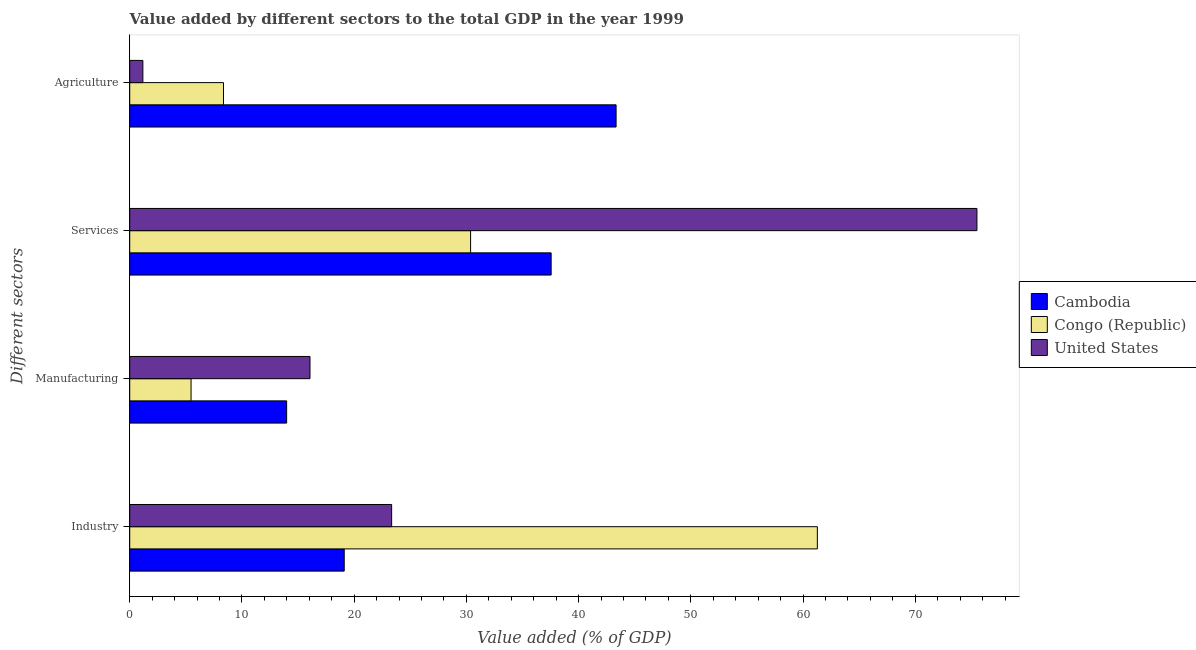How many different coloured bars are there?
Your answer should be compact. 3. How many groups of bars are there?
Keep it short and to the point. 4. What is the label of the 2nd group of bars from the top?
Offer a very short reply. Services. What is the value added by agricultural sector in United States?
Provide a succinct answer. 1.17. Across all countries, what is the maximum value added by agricultural sector?
Give a very brief answer. 43.34. Across all countries, what is the minimum value added by services sector?
Your answer should be very brief. 30.37. In which country was the value added by agricultural sector maximum?
Provide a short and direct response. Cambodia. In which country was the value added by services sector minimum?
Give a very brief answer. Congo (Republic). What is the total value added by services sector in the graph?
Ensure brevity in your answer.  143.41. What is the difference between the value added by manufacturing sector in United States and that in Cambodia?
Provide a succinct answer. 2.08. What is the difference between the value added by manufacturing sector in Cambodia and the value added by industrial sector in United States?
Give a very brief answer. -9.36. What is the average value added by agricultural sector per country?
Make the answer very short. 17.62. What is the difference between the value added by services sector and value added by manufacturing sector in Cambodia?
Your answer should be compact. 23.57. What is the ratio of the value added by agricultural sector in Cambodia to that in Congo (Republic)?
Make the answer very short. 5.19. Is the value added by industrial sector in Congo (Republic) less than that in Cambodia?
Ensure brevity in your answer.  No. What is the difference between the highest and the second highest value added by services sector?
Offer a very short reply. 37.94. What is the difference between the highest and the lowest value added by industrial sector?
Offer a very short reply. 42.16. In how many countries, is the value added by services sector greater than the average value added by services sector taken over all countries?
Keep it short and to the point. 1. Is the sum of the value added by services sector in Congo (Republic) and United States greater than the maximum value added by manufacturing sector across all countries?
Your response must be concise. Yes. Is it the case that in every country, the sum of the value added by industrial sector and value added by manufacturing sector is greater than the sum of value added by agricultural sector and value added by services sector?
Offer a very short reply. No. What does the 2nd bar from the top in Services represents?
Your response must be concise. Congo (Republic). What does the 1st bar from the bottom in Manufacturing represents?
Make the answer very short. Cambodia. Are all the bars in the graph horizontal?
Ensure brevity in your answer.  Yes. How many countries are there in the graph?
Provide a short and direct response. 3. Are the values on the major ticks of X-axis written in scientific E-notation?
Your answer should be very brief. No. Does the graph contain grids?
Ensure brevity in your answer.  No. Where does the legend appear in the graph?
Your response must be concise. Center right. How many legend labels are there?
Make the answer very short. 3. What is the title of the graph?
Your answer should be compact. Value added by different sectors to the total GDP in the year 1999. Does "Turks and Caicos Islands" appear as one of the legend labels in the graph?
Your answer should be very brief. No. What is the label or title of the X-axis?
Make the answer very short. Value added (% of GDP). What is the label or title of the Y-axis?
Offer a terse response. Different sectors. What is the Value added (% of GDP) of Cambodia in Industry?
Make the answer very short. 19.11. What is the Value added (% of GDP) in Congo (Republic) in Industry?
Make the answer very short. 61.27. What is the Value added (% of GDP) of United States in Industry?
Provide a short and direct response. 23.34. What is the Value added (% of GDP) in Cambodia in Manufacturing?
Your answer should be compact. 13.98. What is the Value added (% of GDP) of Congo (Republic) in Manufacturing?
Offer a very short reply. 5.46. What is the Value added (% of GDP) of United States in Manufacturing?
Keep it short and to the point. 16.06. What is the Value added (% of GDP) in Cambodia in Services?
Offer a very short reply. 37.55. What is the Value added (% of GDP) of Congo (Republic) in Services?
Give a very brief answer. 30.37. What is the Value added (% of GDP) of United States in Services?
Make the answer very short. 75.49. What is the Value added (% of GDP) of Cambodia in Agriculture?
Provide a short and direct response. 43.34. What is the Value added (% of GDP) of Congo (Republic) in Agriculture?
Give a very brief answer. 8.36. What is the Value added (% of GDP) in United States in Agriculture?
Your answer should be very brief. 1.17. Across all Different sectors, what is the maximum Value added (% of GDP) of Cambodia?
Offer a terse response. 43.34. Across all Different sectors, what is the maximum Value added (% of GDP) in Congo (Republic)?
Provide a short and direct response. 61.27. Across all Different sectors, what is the maximum Value added (% of GDP) of United States?
Make the answer very short. 75.49. Across all Different sectors, what is the minimum Value added (% of GDP) in Cambodia?
Your response must be concise. 13.98. Across all Different sectors, what is the minimum Value added (% of GDP) in Congo (Republic)?
Offer a very short reply. 5.46. Across all Different sectors, what is the minimum Value added (% of GDP) of United States?
Give a very brief answer. 1.17. What is the total Value added (% of GDP) of Cambodia in the graph?
Make the answer very short. 113.98. What is the total Value added (% of GDP) of Congo (Republic) in the graph?
Your response must be concise. 105.46. What is the total Value added (% of GDP) of United States in the graph?
Your response must be concise. 116.06. What is the difference between the Value added (% of GDP) of Cambodia in Industry and that in Manufacturing?
Make the answer very short. 5.13. What is the difference between the Value added (% of GDP) of Congo (Republic) in Industry and that in Manufacturing?
Offer a terse response. 55.81. What is the difference between the Value added (% of GDP) of United States in Industry and that in Manufacturing?
Offer a terse response. 7.28. What is the difference between the Value added (% of GDP) of Cambodia in Industry and that in Services?
Your answer should be very brief. -18.44. What is the difference between the Value added (% of GDP) in Congo (Republic) in Industry and that in Services?
Your answer should be compact. 30.9. What is the difference between the Value added (% of GDP) of United States in Industry and that in Services?
Ensure brevity in your answer.  -52.15. What is the difference between the Value added (% of GDP) of Cambodia in Industry and that in Agriculture?
Ensure brevity in your answer.  -24.22. What is the difference between the Value added (% of GDP) of Congo (Republic) in Industry and that in Agriculture?
Give a very brief answer. 52.92. What is the difference between the Value added (% of GDP) of United States in Industry and that in Agriculture?
Offer a very short reply. 22.17. What is the difference between the Value added (% of GDP) in Cambodia in Manufacturing and that in Services?
Make the answer very short. -23.57. What is the difference between the Value added (% of GDP) in Congo (Republic) in Manufacturing and that in Services?
Ensure brevity in your answer.  -24.91. What is the difference between the Value added (% of GDP) in United States in Manufacturing and that in Services?
Provide a succinct answer. -59.43. What is the difference between the Value added (% of GDP) in Cambodia in Manufacturing and that in Agriculture?
Make the answer very short. -29.36. What is the difference between the Value added (% of GDP) of Congo (Republic) in Manufacturing and that in Agriculture?
Your answer should be compact. -2.89. What is the difference between the Value added (% of GDP) of United States in Manufacturing and that in Agriculture?
Give a very brief answer. 14.89. What is the difference between the Value added (% of GDP) in Cambodia in Services and that in Agriculture?
Give a very brief answer. -5.79. What is the difference between the Value added (% of GDP) in Congo (Republic) in Services and that in Agriculture?
Provide a succinct answer. 22.02. What is the difference between the Value added (% of GDP) of United States in Services and that in Agriculture?
Your response must be concise. 74.32. What is the difference between the Value added (% of GDP) in Cambodia in Industry and the Value added (% of GDP) in Congo (Republic) in Manufacturing?
Offer a very short reply. 13.65. What is the difference between the Value added (% of GDP) of Cambodia in Industry and the Value added (% of GDP) of United States in Manufacturing?
Your answer should be very brief. 3.05. What is the difference between the Value added (% of GDP) in Congo (Republic) in Industry and the Value added (% of GDP) in United States in Manufacturing?
Your response must be concise. 45.21. What is the difference between the Value added (% of GDP) of Cambodia in Industry and the Value added (% of GDP) of Congo (Republic) in Services?
Offer a very short reply. -11.26. What is the difference between the Value added (% of GDP) in Cambodia in Industry and the Value added (% of GDP) in United States in Services?
Ensure brevity in your answer.  -56.38. What is the difference between the Value added (% of GDP) in Congo (Republic) in Industry and the Value added (% of GDP) in United States in Services?
Give a very brief answer. -14.22. What is the difference between the Value added (% of GDP) of Cambodia in Industry and the Value added (% of GDP) of Congo (Republic) in Agriculture?
Provide a short and direct response. 10.76. What is the difference between the Value added (% of GDP) in Cambodia in Industry and the Value added (% of GDP) in United States in Agriculture?
Ensure brevity in your answer.  17.94. What is the difference between the Value added (% of GDP) in Congo (Republic) in Industry and the Value added (% of GDP) in United States in Agriculture?
Ensure brevity in your answer.  60.1. What is the difference between the Value added (% of GDP) of Cambodia in Manufacturing and the Value added (% of GDP) of Congo (Republic) in Services?
Provide a succinct answer. -16.39. What is the difference between the Value added (% of GDP) of Cambodia in Manufacturing and the Value added (% of GDP) of United States in Services?
Your answer should be compact. -61.51. What is the difference between the Value added (% of GDP) of Congo (Republic) in Manufacturing and the Value added (% of GDP) of United States in Services?
Offer a terse response. -70.03. What is the difference between the Value added (% of GDP) of Cambodia in Manufacturing and the Value added (% of GDP) of Congo (Republic) in Agriculture?
Ensure brevity in your answer.  5.63. What is the difference between the Value added (% of GDP) of Cambodia in Manufacturing and the Value added (% of GDP) of United States in Agriculture?
Provide a short and direct response. 12.81. What is the difference between the Value added (% of GDP) in Congo (Republic) in Manufacturing and the Value added (% of GDP) in United States in Agriculture?
Your response must be concise. 4.29. What is the difference between the Value added (% of GDP) in Cambodia in Services and the Value added (% of GDP) in Congo (Republic) in Agriculture?
Provide a succinct answer. 29.19. What is the difference between the Value added (% of GDP) of Cambodia in Services and the Value added (% of GDP) of United States in Agriculture?
Provide a short and direct response. 36.38. What is the difference between the Value added (% of GDP) of Congo (Republic) in Services and the Value added (% of GDP) of United States in Agriculture?
Your answer should be very brief. 29.2. What is the average Value added (% of GDP) in Cambodia per Different sectors?
Your response must be concise. 28.5. What is the average Value added (% of GDP) of Congo (Republic) per Different sectors?
Provide a short and direct response. 26.37. What is the average Value added (% of GDP) in United States per Different sectors?
Ensure brevity in your answer.  29.02. What is the difference between the Value added (% of GDP) in Cambodia and Value added (% of GDP) in Congo (Republic) in Industry?
Keep it short and to the point. -42.16. What is the difference between the Value added (% of GDP) of Cambodia and Value added (% of GDP) of United States in Industry?
Make the answer very short. -4.22. What is the difference between the Value added (% of GDP) of Congo (Republic) and Value added (% of GDP) of United States in Industry?
Offer a very short reply. 37.93. What is the difference between the Value added (% of GDP) of Cambodia and Value added (% of GDP) of Congo (Republic) in Manufacturing?
Provide a short and direct response. 8.52. What is the difference between the Value added (% of GDP) in Cambodia and Value added (% of GDP) in United States in Manufacturing?
Keep it short and to the point. -2.08. What is the difference between the Value added (% of GDP) in Congo (Republic) and Value added (% of GDP) in United States in Manufacturing?
Your answer should be compact. -10.6. What is the difference between the Value added (% of GDP) in Cambodia and Value added (% of GDP) in Congo (Republic) in Services?
Your answer should be very brief. 7.18. What is the difference between the Value added (% of GDP) of Cambodia and Value added (% of GDP) of United States in Services?
Your answer should be compact. -37.94. What is the difference between the Value added (% of GDP) of Congo (Republic) and Value added (% of GDP) of United States in Services?
Ensure brevity in your answer.  -45.12. What is the difference between the Value added (% of GDP) in Cambodia and Value added (% of GDP) in Congo (Republic) in Agriculture?
Ensure brevity in your answer.  34.98. What is the difference between the Value added (% of GDP) of Cambodia and Value added (% of GDP) of United States in Agriculture?
Ensure brevity in your answer.  42.17. What is the difference between the Value added (% of GDP) in Congo (Republic) and Value added (% of GDP) in United States in Agriculture?
Your response must be concise. 7.18. What is the ratio of the Value added (% of GDP) of Cambodia in Industry to that in Manufacturing?
Offer a very short reply. 1.37. What is the ratio of the Value added (% of GDP) in Congo (Republic) in Industry to that in Manufacturing?
Your answer should be compact. 11.21. What is the ratio of the Value added (% of GDP) of United States in Industry to that in Manufacturing?
Offer a very short reply. 1.45. What is the ratio of the Value added (% of GDP) of Cambodia in Industry to that in Services?
Provide a short and direct response. 0.51. What is the ratio of the Value added (% of GDP) in Congo (Republic) in Industry to that in Services?
Give a very brief answer. 2.02. What is the ratio of the Value added (% of GDP) in United States in Industry to that in Services?
Provide a succinct answer. 0.31. What is the ratio of the Value added (% of GDP) of Cambodia in Industry to that in Agriculture?
Ensure brevity in your answer.  0.44. What is the ratio of the Value added (% of GDP) of Congo (Republic) in Industry to that in Agriculture?
Make the answer very short. 7.33. What is the ratio of the Value added (% of GDP) of United States in Industry to that in Agriculture?
Provide a short and direct response. 19.92. What is the ratio of the Value added (% of GDP) in Cambodia in Manufacturing to that in Services?
Ensure brevity in your answer.  0.37. What is the ratio of the Value added (% of GDP) in Congo (Republic) in Manufacturing to that in Services?
Provide a succinct answer. 0.18. What is the ratio of the Value added (% of GDP) of United States in Manufacturing to that in Services?
Make the answer very short. 0.21. What is the ratio of the Value added (% of GDP) of Cambodia in Manufacturing to that in Agriculture?
Ensure brevity in your answer.  0.32. What is the ratio of the Value added (% of GDP) of Congo (Republic) in Manufacturing to that in Agriculture?
Provide a succinct answer. 0.65. What is the ratio of the Value added (% of GDP) of United States in Manufacturing to that in Agriculture?
Ensure brevity in your answer.  13.71. What is the ratio of the Value added (% of GDP) of Cambodia in Services to that in Agriculture?
Provide a short and direct response. 0.87. What is the ratio of the Value added (% of GDP) in Congo (Republic) in Services to that in Agriculture?
Ensure brevity in your answer.  3.63. What is the ratio of the Value added (% of GDP) of United States in Services to that in Agriculture?
Provide a short and direct response. 64.45. What is the difference between the highest and the second highest Value added (% of GDP) in Cambodia?
Your response must be concise. 5.79. What is the difference between the highest and the second highest Value added (% of GDP) of Congo (Republic)?
Provide a succinct answer. 30.9. What is the difference between the highest and the second highest Value added (% of GDP) in United States?
Your answer should be compact. 52.15. What is the difference between the highest and the lowest Value added (% of GDP) in Cambodia?
Provide a succinct answer. 29.36. What is the difference between the highest and the lowest Value added (% of GDP) of Congo (Republic)?
Your answer should be very brief. 55.81. What is the difference between the highest and the lowest Value added (% of GDP) of United States?
Your answer should be very brief. 74.32. 